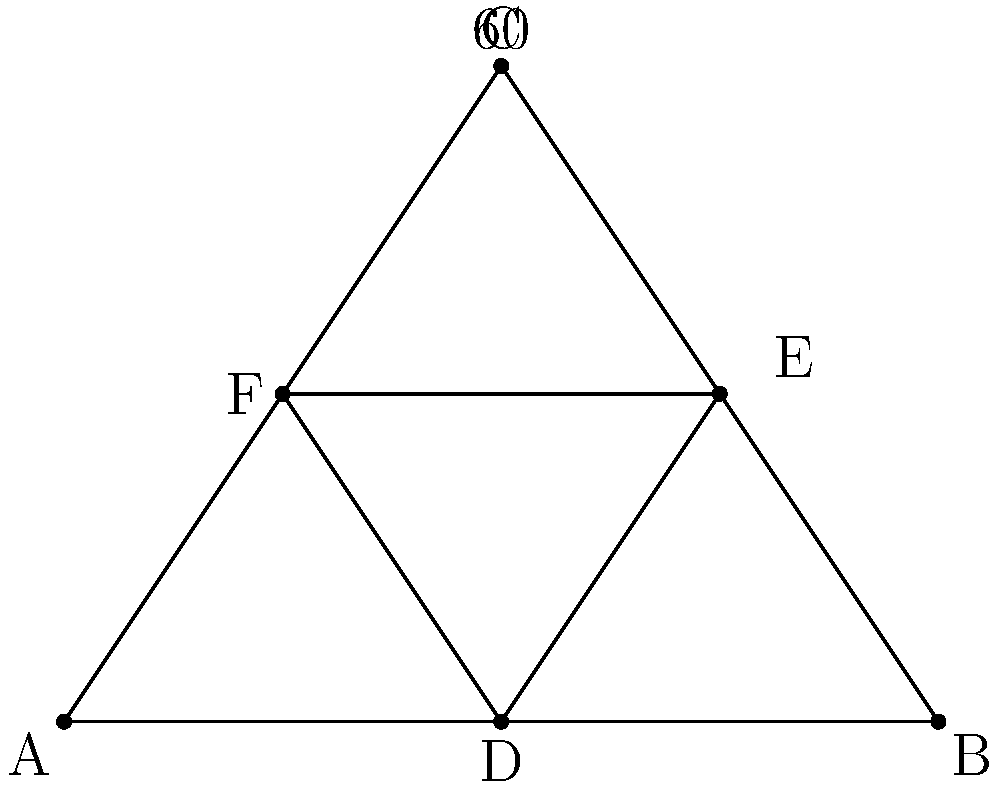For the Diwali festival, you're designing a stylized lotus flower decoration using two equilateral triangles. The outer triangle ABC represents the petals, while the inner triangle DEF represents the center. If the angle at vertex C is 60°, what is the ratio of the area of the inner triangle DEF to the area of the outer triangle ABC? Let's approach this step-by-step:

1) First, we need to recognize that both triangles are equilateral. This is because:
   - We're told that angle C is 60°, which is characteristic of an equilateral triangle.
   - The inner triangle is formed by connecting the midpoints of the outer triangle's sides, which always results in an equilateral triangle.

2) For an equilateral triangle, the area is given by the formula:
   $A = \frac{\sqrt{3}}{4}a^2$, where $a$ is the side length.

3) Let's say the side length of the outer triangle ABC is $a$. Then:
   Area of ABC = $\frac{\sqrt{3}}{4}a^2$

4) The inner triangle DEF is formed by connecting the midpoints of ABC. This means each side of DEF is half the length of ABC's sides:
   Side of DEF = $\frac{1}{2}a$

5) Therefore, the area of DEF is:
   Area of DEF = $\frac{\sqrt{3}}{4}(\frac{1}{2}a)^2 = \frac{\sqrt{3}}{4} \cdot \frac{1}{4}a^2 = \frac{\sqrt{3}}{16}a^2$

6) The ratio of the areas is:
   $\frac{\text{Area of DEF}}{\text{Area of ABC}} = \frac{\frac{\sqrt{3}}{16}a^2}{\frac{\sqrt{3}}{4}a^2} = \frac{1}{4}$

Therefore, the area of the inner triangle is $\frac{1}{4}$ or $25\%$ of the area of the outer triangle.
Answer: $1:4$ or $0.25$ or $25\%$ 